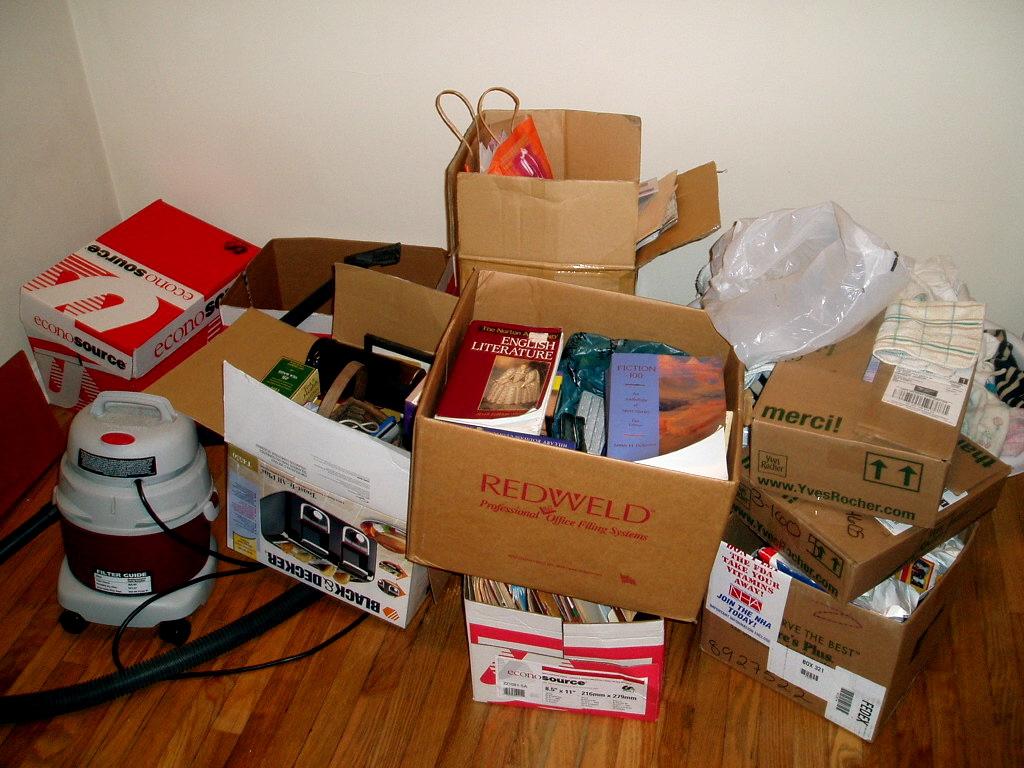What does the box with red lettering say?
Your answer should be compact. Redweld. 